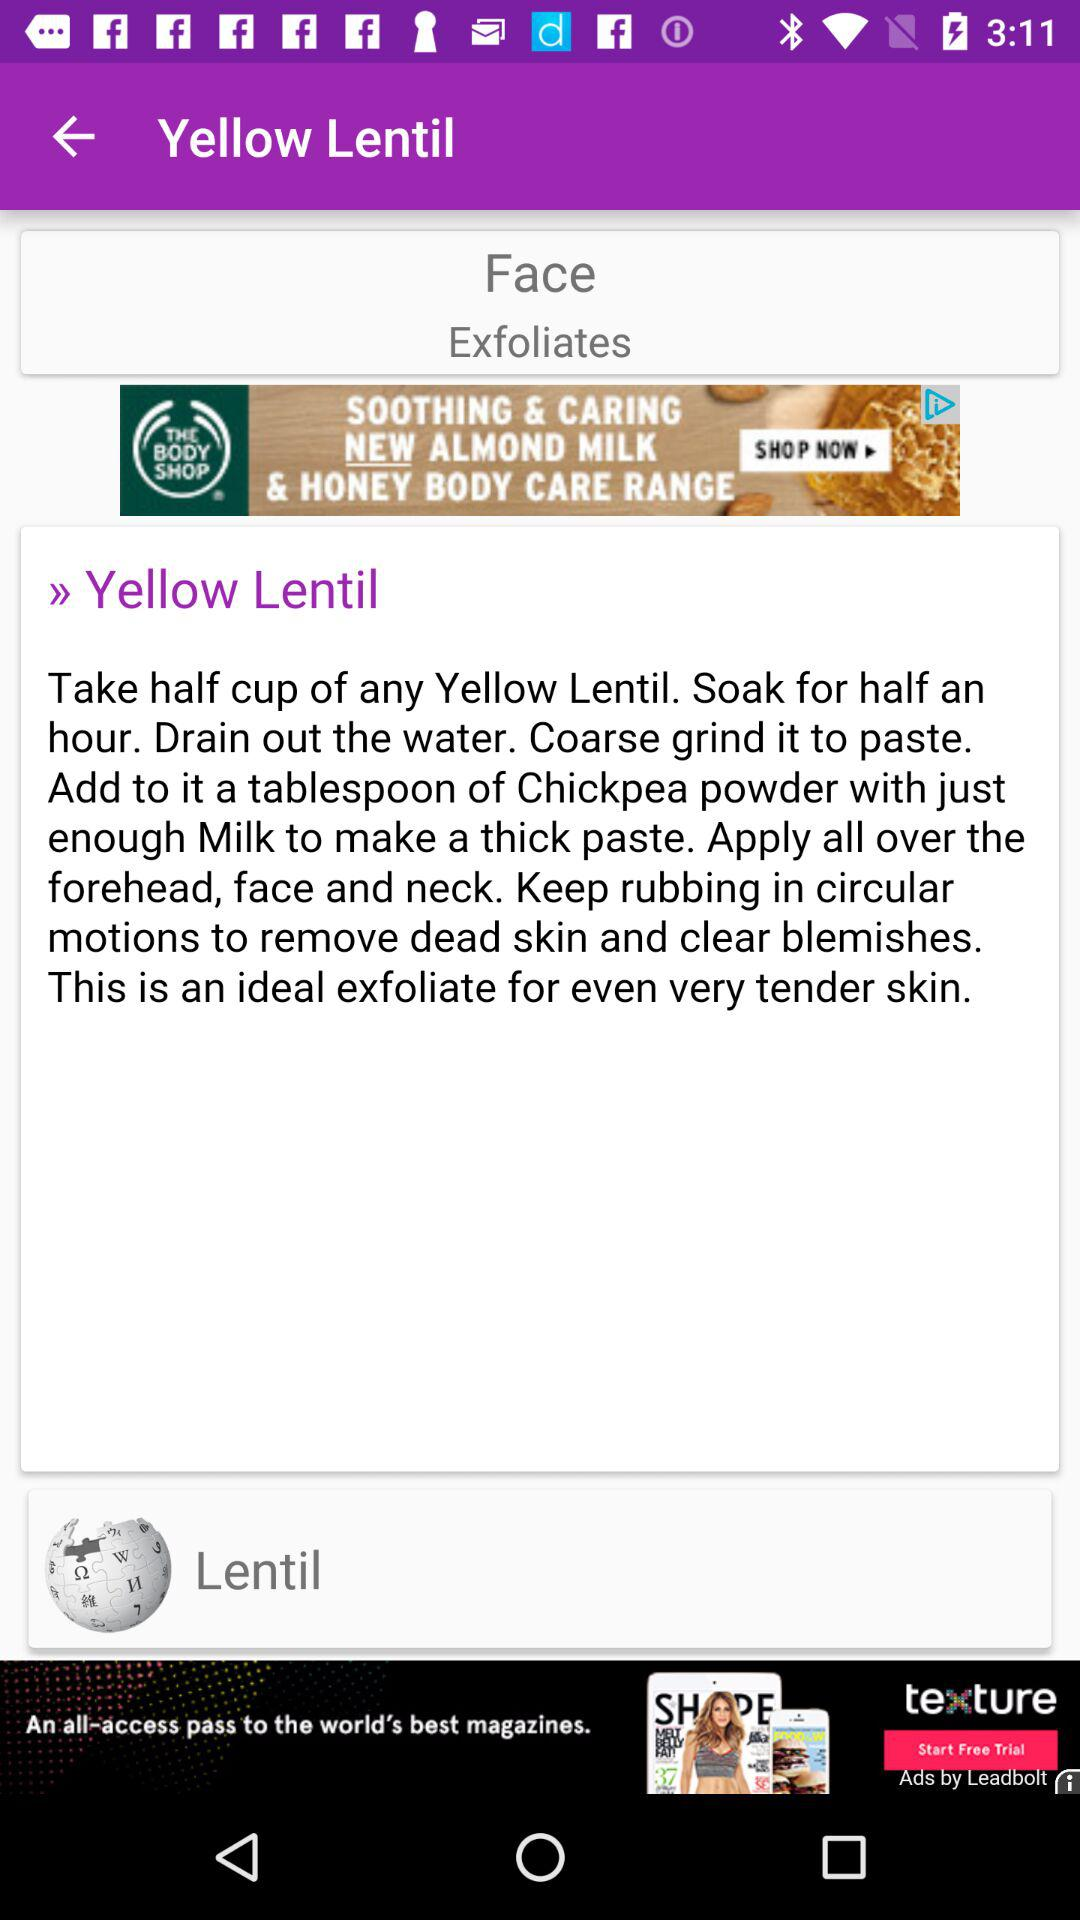What is Yellow Lentil?
When the provided information is insufficient, respond with <no answer>. <no answer> 